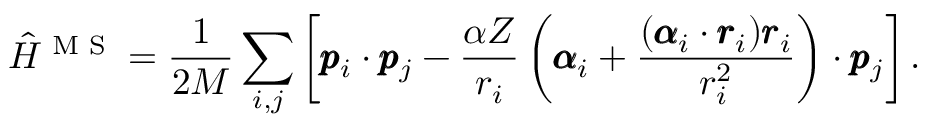<formula> <loc_0><loc_0><loc_500><loc_500>\hat { H } ^ { M S } = \frac { 1 } { 2 M } \sum _ { i , j } \left [ \pm b { p } _ { i } \cdot \pm b { p } _ { j } - \frac { \alpha Z } { r _ { i } } \left ( \pm b { \alpha } _ { i } + \frac { ( \pm b { \alpha } _ { i } \cdot \pm b { r } _ { i } ) \pm b { r } _ { i } } { r _ { i } ^ { 2 } } \right ) \cdot \pm b { p } _ { j } \right ] .</formula> 